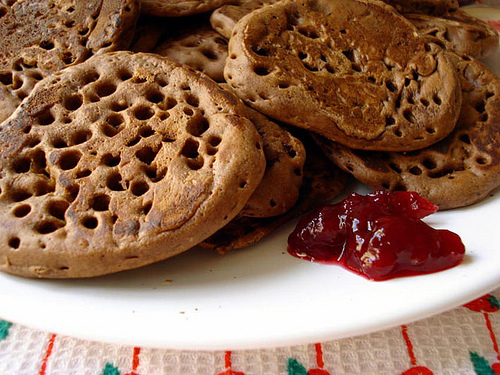<image>
Can you confirm if the ketchup is in front of the cookie? Yes. The ketchup is positioned in front of the cookie, appearing closer to the camera viewpoint. 